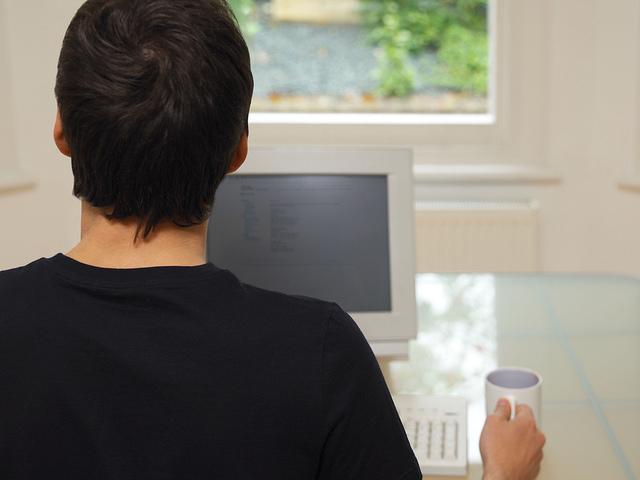How many windows are there?
Give a very brief answer. 1. How many people are in the photo?
Give a very brief answer. 1. 